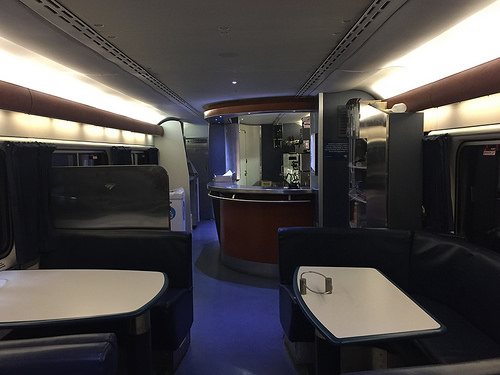<image>
Is there a couch to the left of the table? No. The couch is not to the left of the table. From this viewpoint, they have a different horizontal relationship. 